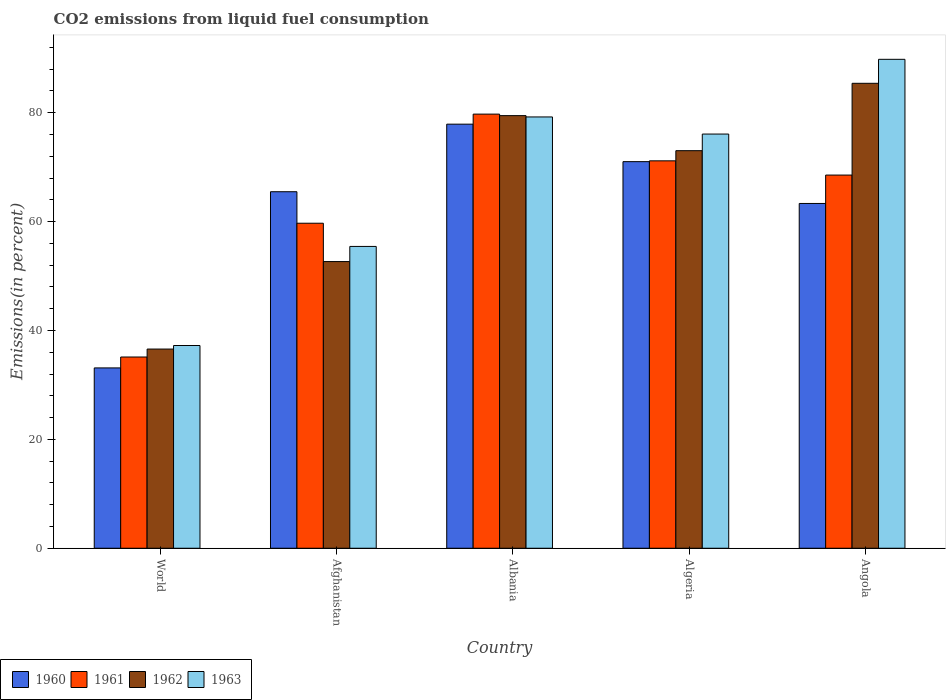How many different coloured bars are there?
Provide a succinct answer. 4. Are the number of bars per tick equal to the number of legend labels?
Offer a terse response. Yes. Are the number of bars on each tick of the X-axis equal?
Offer a terse response. Yes. How many bars are there on the 1st tick from the left?
Make the answer very short. 4. How many bars are there on the 5th tick from the right?
Provide a succinct answer. 4. What is the label of the 3rd group of bars from the left?
Your answer should be compact. Albania. What is the total CO2 emitted in 1963 in Albania?
Make the answer very short. 79.23. Across all countries, what is the maximum total CO2 emitted in 1960?
Your response must be concise. 77.9. Across all countries, what is the minimum total CO2 emitted in 1962?
Offer a very short reply. 36.59. In which country was the total CO2 emitted in 1960 maximum?
Your response must be concise. Albania. What is the total total CO2 emitted in 1962 in the graph?
Your answer should be compact. 327.14. What is the difference between the total CO2 emitted in 1960 in Afghanistan and that in World?
Your answer should be compact. 32.36. What is the difference between the total CO2 emitted in 1962 in Angola and the total CO2 emitted in 1960 in Algeria?
Provide a short and direct response. 14.39. What is the average total CO2 emitted in 1961 per country?
Give a very brief answer. 62.86. What is the difference between the total CO2 emitted of/in 1960 and total CO2 emitted of/in 1963 in World?
Give a very brief answer. -4.11. What is the ratio of the total CO2 emitted in 1962 in Albania to that in Angola?
Your answer should be very brief. 0.93. Is the difference between the total CO2 emitted in 1960 in Afghanistan and Angola greater than the difference between the total CO2 emitted in 1963 in Afghanistan and Angola?
Ensure brevity in your answer.  Yes. What is the difference between the highest and the second highest total CO2 emitted in 1960?
Keep it short and to the point. -12.41. What is the difference between the highest and the lowest total CO2 emitted in 1960?
Your answer should be very brief. 44.77. Is the sum of the total CO2 emitted in 1963 in Algeria and World greater than the maximum total CO2 emitted in 1962 across all countries?
Give a very brief answer. Yes. Are all the bars in the graph horizontal?
Offer a terse response. No. What is the difference between two consecutive major ticks on the Y-axis?
Make the answer very short. 20. Are the values on the major ticks of Y-axis written in scientific E-notation?
Keep it short and to the point. No. Does the graph contain any zero values?
Offer a terse response. No. Does the graph contain grids?
Your answer should be very brief. No. How are the legend labels stacked?
Offer a terse response. Horizontal. What is the title of the graph?
Offer a very short reply. CO2 emissions from liquid fuel consumption. What is the label or title of the X-axis?
Offer a very short reply. Country. What is the label or title of the Y-axis?
Ensure brevity in your answer.  Emissions(in percent). What is the Emissions(in percent) of 1960 in World?
Make the answer very short. 33.13. What is the Emissions(in percent) of 1961 in World?
Provide a short and direct response. 35.13. What is the Emissions(in percent) in 1962 in World?
Ensure brevity in your answer.  36.59. What is the Emissions(in percent) of 1963 in World?
Keep it short and to the point. 37.24. What is the Emissions(in percent) in 1960 in Afghanistan?
Offer a very short reply. 65.49. What is the Emissions(in percent) in 1961 in Afghanistan?
Provide a short and direct response. 59.7. What is the Emissions(in percent) in 1962 in Afghanistan?
Offer a terse response. 52.66. What is the Emissions(in percent) in 1963 in Afghanistan?
Ensure brevity in your answer.  55.44. What is the Emissions(in percent) in 1960 in Albania?
Offer a very short reply. 77.9. What is the Emissions(in percent) in 1961 in Albania?
Make the answer very short. 79.74. What is the Emissions(in percent) in 1962 in Albania?
Provide a succinct answer. 79.46. What is the Emissions(in percent) in 1963 in Albania?
Your response must be concise. 79.23. What is the Emissions(in percent) of 1960 in Algeria?
Keep it short and to the point. 71.01. What is the Emissions(in percent) of 1961 in Algeria?
Give a very brief answer. 71.16. What is the Emissions(in percent) of 1962 in Algeria?
Offer a very short reply. 73.03. What is the Emissions(in percent) of 1963 in Algeria?
Keep it short and to the point. 76.08. What is the Emissions(in percent) in 1960 in Angola?
Offer a terse response. 63.33. What is the Emissions(in percent) in 1961 in Angola?
Offer a very short reply. 68.55. What is the Emissions(in percent) of 1962 in Angola?
Your answer should be very brief. 85.4. What is the Emissions(in percent) of 1963 in Angola?
Your answer should be very brief. 89.81. Across all countries, what is the maximum Emissions(in percent) in 1960?
Your answer should be compact. 77.9. Across all countries, what is the maximum Emissions(in percent) in 1961?
Keep it short and to the point. 79.74. Across all countries, what is the maximum Emissions(in percent) in 1962?
Provide a short and direct response. 85.4. Across all countries, what is the maximum Emissions(in percent) in 1963?
Your answer should be very brief. 89.81. Across all countries, what is the minimum Emissions(in percent) of 1960?
Your answer should be compact. 33.13. Across all countries, what is the minimum Emissions(in percent) in 1961?
Your answer should be very brief. 35.13. Across all countries, what is the minimum Emissions(in percent) in 1962?
Provide a succinct answer. 36.59. Across all countries, what is the minimum Emissions(in percent) in 1963?
Offer a terse response. 37.24. What is the total Emissions(in percent) of 1960 in the graph?
Offer a very short reply. 310.86. What is the total Emissions(in percent) in 1961 in the graph?
Offer a terse response. 314.28. What is the total Emissions(in percent) in 1962 in the graph?
Provide a short and direct response. 327.14. What is the total Emissions(in percent) in 1963 in the graph?
Provide a short and direct response. 337.8. What is the difference between the Emissions(in percent) in 1960 in World and that in Afghanistan?
Your response must be concise. -32.36. What is the difference between the Emissions(in percent) in 1961 in World and that in Afghanistan?
Provide a short and direct response. -24.57. What is the difference between the Emissions(in percent) of 1962 in World and that in Afghanistan?
Make the answer very short. -16.07. What is the difference between the Emissions(in percent) of 1963 in World and that in Afghanistan?
Offer a very short reply. -18.2. What is the difference between the Emissions(in percent) in 1960 in World and that in Albania?
Provide a short and direct response. -44.77. What is the difference between the Emissions(in percent) of 1961 in World and that in Albania?
Provide a short and direct response. -44.61. What is the difference between the Emissions(in percent) in 1962 in World and that in Albania?
Your answer should be very brief. -42.88. What is the difference between the Emissions(in percent) of 1963 in World and that in Albania?
Keep it short and to the point. -41.99. What is the difference between the Emissions(in percent) of 1960 in World and that in Algeria?
Keep it short and to the point. -37.89. What is the difference between the Emissions(in percent) in 1961 in World and that in Algeria?
Your answer should be very brief. -36.03. What is the difference between the Emissions(in percent) in 1962 in World and that in Algeria?
Provide a short and direct response. -36.44. What is the difference between the Emissions(in percent) of 1963 in World and that in Algeria?
Make the answer very short. -38.84. What is the difference between the Emissions(in percent) in 1960 in World and that in Angola?
Keep it short and to the point. -30.21. What is the difference between the Emissions(in percent) of 1961 in World and that in Angola?
Ensure brevity in your answer.  -33.42. What is the difference between the Emissions(in percent) of 1962 in World and that in Angola?
Provide a short and direct response. -48.82. What is the difference between the Emissions(in percent) in 1963 in World and that in Angola?
Offer a terse response. -52.57. What is the difference between the Emissions(in percent) in 1960 in Afghanistan and that in Albania?
Make the answer very short. -12.41. What is the difference between the Emissions(in percent) of 1961 in Afghanistan and that in Albania?
Your response must be concise. -20.04. What is the difference between the Emissions(in percent) of 1962 in Afghanistan and that in Albania?
Your answer should be compact. -26.8. What is the difference between the Emissions(in percent) in 1963 in Afghanistan and that in Albania?
Provide a short and direct response. -23.78. What is the difference between the Emissions(in percent) of 1960 in Afghanistan and that in Algeria?
Make the answer very short. -5.53. What is the difference between the Emissions(in percent) of 1961 in Afghanistan and that in Algeria?
Your response must be concise. -11.46. What is the difference between the Emissions(in percent) of 1962 in Afghanistan and that in Algeria?
Your answer should be compact. -20.37. What is the difference between the Emissions(in percent) in 1963 in Afghanistan and that in Algeria?
Your response must be concise. -20.64. What is the difference between the Emissions(in percent) in 1960 in Afghanistan and that in Angola?
Your response must be concise. 2.15. What is the difference between the Emissions(in percent) in 1961 in Afghanistan and that in Angola?
Ensure brevity in your answer.  -8.85. What is the difference between the Emissions(in percent) of 1962 in Afghanistan and that in Angola?
Ensure brevity in your answer.  -32.74. What is the difference between the Emissions(in percent) in 1963 in Afghanistan and that in Angola?
Offer a terse response. -34.37. What is the difference between the Emissions(in percent) in 1960 in Albania and that in Algeria?
Keep it short and to the point. 6.89. What is the difference between the Emissions(in percent) of 1961 in Albania and that in Algeria?
Ensure brevity in your answer.  8.58. What is the difference between the Emissions(in percent) in 1962 in Albania and that in Algeria?
Offer a terse response. 6.44. What is the difference between the Emissions(in percent) in 1963 in Albania and that in Algeria?
Your answer should be very brief. 3.14. What is the difference between the Emissions(in percent) of 1960 in Albania and that in Angola?
Your answer should be very brief. 14.57. What is the difference between the Emissions(in percent) of 1961 in Albania and that in Angola?
Your response must be concise. 11.19. What is the difference between the Emissions(in percent) in 1962 in Albania and that in Angola?
Your response must be concise. -5.94. What is the difference between the Emissions(in percent) in 1963 in Albania and that in Angola?
Offer a very short reply. -10.58. What is the difference between the Emissions(in percent) in 1960 in Algeria and that in Angola?
Offer a terse response. 7.68. What is the difference between the Emissions(in percent) of 1961 in Algeria and that in Angola?
Offer a terse response. 2.61. What is the difference between the Emissions(in percent) of 1962 in Algeria and that in Angola?
Your answer should be compact. -12.38. What is the difference between the Emissions(in percent) of 1963 in Algeria and that in Angola?
Your answer should be very brief. -13.73. What is the difference between the Emissions(in percent) of 1960 in World and the Emissions(in percent) of 1961 in Afghanistan?
Provide a short and direct response. -26.58. What is the difference between the Emissions(in percent) of 1960 in World and the Emissions(in percent) of 1962 in Afghanistan?
Your response must be concise. -19.53. What is the difference between the Emissions(in percent) in 1960 in World and the Emissions(in percent) in 1963 in Afghanistan?
Ensure brevity in your answer.  -22.32. What is the difference between the Emissions(in percent) in 1961 in World and the Emissions(in percent) in 1962 in Afghanistan?
Provide a short and direct response. -17.53. What is the difference between the Emissions(in percent) in 1961 in World and the Emissions(in percent) in 1963 in Afghanistan?
Make the answer very short. -20.31. What is the difference between the Emissions(in percent) in 1962 in World and the Emissions(in percent) in 1963 in Afghanistan?
Offer a very short reply. -18.85. What is the difference between the Emissions(in percent) in 1960 in World and the Emissions(in percent) in 1961 in Albania?
Ensure brevity in your answer.  -46.62. What is the difference between the Emissions(in percent) in 1960 in World and the Emissions(in percent) in 1962 in Albania?
Make the answer very short. -46.34. What is the difference between the Emissions(in percent) in 1960 in World and the Emissions(in percent) in 1963 in Albania?
Your answer should be compact. -46.1. What is the difference between the Emissions(in percent) in 1961 in World and the Emissions(in percent) in 1962 in Albania?
Your response must be concise. -44.34. What is the difference between the Emissions(in percent) in 1961 in World and the Emissions(in percent) in 1963 in Albania?
Offer a terse response. -44.1. What is the difference between the Emissions(in percent) of 1962 in World and the Emissions(in percent) of 1963 in Albania?
Give a very brief answer. -42.64. What is the difference between the Emissions(in percent) in 1960 in World and the Emissions(in percent) in 1961 in Algeria?
Your answer should be very brief. -38.04. What is the difference between the Emissions(in percent) of 1960 in World and the Emissions(in percent) of 1962 in Algeria?
Your answer should be very brief. -39.9. What is the difference between the Emissions(in percent) of 1960 in World and the Emissions(in percent) of 1963 in Algeria?
Provide a succinct answer. -42.96. What is the difference between the Emissions(in percent) in 1961 in World and the Emissions(in percent) in 1962 in Algeria?
Your response must be concise. -37.9. What is the difference between the Emissions(in percent) in 1961 in World and the Emissions(in percent) in 1963 in Algeria?
Your answer should be very brief. -40.95. What is the difference between the Emissions(in percent) in 1962 in World and the Emissions(in percent) in 1963 in Algeria?
Provide a succinct answer. -39.49. What is the difference between the Emissions(in percent) in 1960 in World and the Emissions(in percent) in 1961 in Angola?
Give a very brief answer. -35.42. What is the difference between the Emissions(in percent) in 1960 in World and the Emissions(in percent) in 1962 in Angola?
Give a very brief answer. -52.28. What is the difference between the Emissions(in percent) of 1960 in World and the Emissions(in percent) of 1963 in Angola?
Provide a short and direct response. -56.68. What is the difference between the Emissions(in percent) in 1961 in World and the Emissions(in percent) in 1962 in Angola?
Provide a short and direct response. -50.28. What is the difference between the Emissions(in percent) in 1961 in World and the Emissions(in percent) in 1963 in Angola?
Make the answer very short. -54.68. What is the difference between the Emissions(in percent) of 1962 in World and the Emissions(in percent) of 1963 in Angola?
Provide a short and direct response. -53.22. What is the difference between the Emissions(in percent) in 1960 in Afghanistan and the Emissions(in percent) in 1961 in Albania?
Your answer should be compact. -14.26. What is the difference between the Emissions(in percent) in 1960 in Afghanistan and the Emissions(in percent) in 1962 in Albania?
Offer a terse response. -13.98. What is the difference between the Emissions(in percent) in 1960 in Afghanistan and the Emissions(in percent) in 1963 in Albania?
Ensure brevity in your answer.  -13.74. What is the difference between the Emissions(in percent) in 1961 in Afghanistan and the Emissions(in percent) in 1962 in Albania?
Your answer should be compact. -19.76. What is the difference between the Emissions(in percent) in 1961 in Afghanistan and the Emissions(in percent) in 1963 in Albania?
Ensure brevity in your answer.  -19.52. What is the difference between the Emissions(in percent) in 1962 in Afghanistan and the Emissions(in percent) in 1963 in Albania?
Provide a succinct answer. -26.57. What is the difference between the Emissions(in percent) of 1960 in Afghanistan and the Emissions(in percent) of 1961 in Algeria?
Give a very brief answer. -5.67. What is the difference between the Emissions(in percent) of 1960 in Afghanistan and the Emissions(in percent) of 1962 in Algeria?
Your response must be concise. -7.54. What is the difference between the Emissions(in percent) of 1960 in Afghanistan and the Emissions(in percent) of 1963 in Algeria?
Your answer should be compact. -10.59. What is the difference between the Emissions(in percent) in 1961 in Afghanistan and the Emissions(in percent) in 1962 in Algeria?
Keep it short and to the point. -13.33. What is the difference between the Emissions(in percent) in 1961 in Afghanistan and the Emissions(in percent) in 1963 in Algeria?
Your answer should be very brief. -16.38. What is the difference between the Emissions(in percent) of 1962 in Afghanistan and the Emissions(in percent) of 1963 in Algeria?
Your answer should be compact. -23.42. What is the difference between the Emissions(in percent) in 1960 in Afghanistan and the Emissions(in percent) in 1961 in Angola?
Your answer should be very brief. -3.06. What is the difference between the Emissions(in percent) of 1960 in Afghanistan and the Emissions(in percent) of 1962 in Angola?
Keep it short and to the point. -19.92. What is the difference between the Emissions(in percent) of 1960 in Afghanistan and the Emissions(in percent) of 1963 in Angola?
Your answer should be compact. -24.32. What is the difference between the Emissions(in percent) in 1961 in Afghanistan and the Emissions(in percent) in 1962 in Angola?
Ensure brevity in your answer.  -25.7. What is the difference between the Emissions(in percent) of 1961 in Afghanistan and the Emissions(in percent) of 1963 in Angola?
Offer a terse response. -30.11. What is the difference between the Emissions(in percent) of 1962 in Afghanistan and the Emissions(in percent) of 1963 in Angola?
Your response must be concise. -37.15. What is the difference between the Emissions(in percent) of 1960 in Albania and the Emissions(in percent) of 1961 in Algeria?
Provide a succinct answer. 6.74. What is the difference between the Emissions(in percent) of 1960 in Albania and the Emissions(in percent) of 1962 in Algeria?
Your answer should be very brief. 4.87. What is the difference between the Emissions(in percent) in 1960 in Albania and the Emissions(in percent) in 1963 in Algeria?
Provide a short and direct response. 1.82. What is the difference between the Emissions(in percent) of 1961 in Albania and the Emissions(in percent) of 1962 in Algeria?
Your answer should be compact. 6.72. What is the difference between the Emissions(in percent) in 1961 in Albania and the Emissions(in percent) in 1963 in Algeria?
Offer a terse response. 3.66. What is the difference between the Emissions(in percent) of 1962 in Albania and the Emissions(in percent) of 1963 in Algeria?
Keep it short and to the point. 3.38. What is the difference between the Emissions(in percent) in 1960 in Albania and the Emissions(in percent) in 1961 in Angola?
Provide a short and direct response. 9.35. What is the difference between the Emissions(in percent) in 1960 in Albania and the Emissions(in percent) in 1962 in Angola?
Give a very brief answer. -7.51. What is the difference between the Emissions(in percent) of 1960 in Albania and the Emissions(in percent) of 1963 in Angola?
Provide a short and direct response. -11.91. What is the difference between the Emissions(in percent) of 1961 in Albania and the Emissions(in percent) of 1962 in Angola?
Keep it short and to the point. -5.66. What is the difference between the Emissions(in percent) in 1961 in Albania and the Emissions(in percent) in 1963 in Angola?
Make the answer very short. -10.07. What is the difference between the Emissions(in percent) of 1962 in Albania and the Emissions(in percent) of 1963 in Angola?
Offer a very short reply. -10.34. What is the difference between the Emissions(in percent) of 1960 in Algeria and the Emissions(in percent) of 1961 in Angola?
Keep it short and to the point. 2.46. What is the difference between the Emissions(in percent) of 1960 in Algeria and the Emissions(in percent) of 1962 in Angola?
Make the answer very short. -14.39. What is the difference between the Emissions(in percent) in 1960 in Algeria and the Emissions(in percent) in 1963 in Angola?
Your answer should be compact. -18.8. What is the difference between the Emissions(in percent) in 1961 in Algeria and the Emissions(in percent) in 1962 in Angola?
Your answer should be compact. -14.24. What is the difference between the Emissions(in percent) in 1961 in Algeria and the Emissions(in percent) in 1963 in Angola?
Your answer should be very brief. -18.65. What is the difference between the Emissions(in percent) of 1962 in Algeria and the Emissions(in percent) of 1963 in Angola?
Keep it short and to the point. -16.78. What is the average Emissions(in percent) of 1960 per country?
Offer a very short reply. 62.17. What is the average Emissions(in percent) in 1961 per country?
Offer a terse response. 62.86. What is the average Emissions(in percent) in 1962 per country?
Offer a very short reply. 65.43. What is the average Emissions(in percent) in 1963 per country?
Your response must be concise. 67.56. What is the difference between the Emissions(in percent) of 1960 and Emissions(in percent) of 1961 in World?
Make the answer very short. -2. What is the difference between the Emissions(in percent) of 1960 and Emissions(in percent) of 1962 in World?
Give a very brief answer. -3.46. What is the difference between the Emissions(in percent) of 1960 and Emissions(in percent) of 1963 in World?
Your answer should be very brief. -4.11. What is the difference between the Emissions(in percent) in 1961 and Emissions(in percent) in 1962 in World?
Provide a short and direct response. -1.46. What is the difference between the Emissions(in percent) in 1961 and Emissions(in percent) in 1963 in World?
Give a very brief answer. -2.11. What is the difference between the Emissions(in percent) in 1962 and Emissions(in percent) in 1963 in World?
Offer a very short reply. -0.65. What is the difference between the Emissions(in percent) in 1960 and Emissions(in percent) in 1961 in Afghanistan?
Keep it short and to the point. 5.79. What is the difference between the Emissions(in percent) of 1960 and Emissions(in percent) of 1962 in Afghanistan?
Offer a very short reply. 12.83. What is the difference between the Emissions(in percent) in 1960 and Emissions(in percent) in 1963 in Afghanistan?
Make the answer very short. 10.05. What is the difference between the Emissions(in percent) of 1961 and Emissions(in percent) of 1962 in Afghanistan?
Offer a very short reply. 7.04. What is the difference between the Emissions(in percent) in 1961 and Emissions(in percent) in 1963 in Afghanistan?
Your answer should be very brief. 4.26. What is the difference between the Emissions(in percent) of 1962 and Emissions(in percent) of 1963 in Afghanistan?
Give a very brief answer. -2.78. What is the difference between the Emissions(in percent) of 1960 and Emissions(in percent) of 1961 in Albania?
Keep it short and to the point. -1.84. What is the difference between the Emissions(in percent) of 1960 and Emissions(in percent) of 1962 in Albania?
Offer a terse response. -1.57. What is the difference between the Emissions(in percent) in 1960 and Emissions(in percent) in 1963 in Albania?
Your answer should be very brief. -1.33. What is the difference between the Emissions(in percent) in 1961 and Emissions(in percent) in 1962 in Albania?
Your answer should be compact. 0.28. What is the difference between the Emissions(in percent) in 1961 and Emissions(in percent) in 1963 in Albania?
Offer a very short reply. 0.52. What is the difference between the Emissions(in percent) in 1962 and Emissions(in percent) in 1963 in Albania?
Give a very brief answer. 0.24. What is the difference between the Emissions(in percent) in 1960 and Emissions(in percent) in 1961 in Algeria?
Offer a terse response. -0.15. What is the difference between the Emissions(in percent) in 1960 and Emissions(in percent) in 1962 in Algeria?
Offer a terse response. -2.02. What is the difference between the Emissions(in percent) of 1960 and Emissions(in percent) of 1963 in Algeria?
Make the answer very short. -5.07. What is the difference between the Emissions(in percent) in 1961 and Emissions(in percent) in 1962 in Algeria?
Keep it short and to the point. -1.87. What is the difference between the Emissions(in percent) of 1961 and Emissions(in percent) of 1963 in Algeria?
Ensure brevity in your answer.  -4.92. What is the difference between the Emissions(in percent) in 1962 and Emissions(in percent) in 1963 in Algeria?
Provide a succinct answer. -3.05. What is the difference between the Emissions(in percent) in 1960 and Emissions(in percent) in 1961 in Angola?
Keep it short and to the point. -5.22. What is the difference between the Emissions(in percent) of 1960 and Emissions(in percent) of 1962 in Angola?
Your answer should be compact. -22.07. What is the difference between the Emissions(in percent) of 1960 and Emissions(in percent) of 1963 in Angola?
Make the answer very short. -26.48. What is the difference between the Emissions(in percent) of 1961 and Emissions(in percent) of 1962 in Angola?
Your response must be concise. -16.86. What is the difference between the Emissions(in percent) in 1961 and Emissions(in percent) in 1963 in Angola?
Ensure brevity in your answer.  -21.26. What is the difference between the Emissions(in percent) in 1962 and Emissions(in percent) in 1963 in Angola?
Give a very brief answer. -4.41. What is the ratio of the Emissions(in percent) of 1960 in World to that in Afghanistan?
Your response must be concise. 0.51. What is the ratio of the Emissions(in percent) in 1961 in World to that in Afghanistan?
Offer a very short reply. 0.59. What is the ratio of the Emissions(in percent) of 1962 in World to that in Afghanistan?
Your response must be concise. 0.69. What is the ratio of the Emissions(in percent) of 1963 in World to that in Afghanistan?
Your answer should be very brief. 0.67. What is the ratio of the Emissions(in percent) in 1960 in World to that in Albania?
Make the answer very short. 0.43. What is the ratio of the Emissions(in percent) in 1961 in World to that in Albania?
Offer a terse response. 0.44. What is the ratio of the Emissions(in percent) of 1962 in World to that in Albania?
Make the answer very short. 0.46. What is the ratio of the Emissions(in percent) of 1963 in World to that in Albania?
Offer a very short reply. 0.47. What is the ratio of the Emissions(in percent) of 1960 in World to that in Algeria?
Your answer should be very brief. 0.47. What is the ratio of the Emissions(in percent) in 1961 in World to that in Algeria?
Ensure brevity in your answer.  0.49. What is the ratio of the Emissions(in percent) in 1962 in World to that in Algeria?
Ensure brevity in your answer.  0.5. What is the ratio of the Emissions(in percent) in 1963 in World to that in Algeria?
Keep it short and to the point. 0.49. What is the ratio of the Emissions(in percent) of 1960 in World to that in Angola?
Make the answer very short. 0.52. What is the ratio of the Emissions(in percent) of 1961 in World to that in Angola?
Give a very brief answer. 0.51. What is the ratio of the Emissions(in percent) in 1962 in World to that in Angola?
Your answer should be very brief. 0.43. What is the ratio of the Emissions(in percent) in 1963 in World to that in Angola?
Your response must be concise. 0.41. What is the ratio of the Emissions(in percent) of 1960 in Afghanistan to that in Albania?
Your response must be concise. 0.84. What is the ratio of the Emissions(in percent) of 1961 in Afghanistan to that in Albania?
Your answer should be very brief. 0.75. What is the ratio of the Emissions(in percent) of 1962 in Afghanistan to that in Albania?
Keep it short and to the point. 0.66. What is the ratio of the Emissions(in percent) in 1963 in Afghanistan to that in Albania?
Keep it short and to the point. 0.7. What is the ratio of the Emissions(in percent) in 1960 in Afghanistan to that in Algeria?
Offer a terse response. 0.92. What is the ratio of the Emissions(in percent) of 1961 in Afghanistan to that in Algeria?
Offer a terse response. 0.84. What is the ratio of the Emissions(in percent) in 1962 in Afghanistan to that in Algeria?
Your answer should be very brief. 0.72. What is the ratio of the Emissions(in percent) in 1963 in Afghanistan to that in Algeria?
Make the answer very short. 0.73. What is the ratio of the Emissions(in percent) of 1960 in Afghanistan to that in Angola?
Your answer should be compact. 1.03. What is the ratio of the Emissions(in percent) of 1961 in Afghanistan to that in Angola?
Your answer should be compact. 0.87. What is the ratio of the Emissions(in percent) of 1962 in Afghanistan to that in Angola?
Your answer should be very brief. 0.62. What is the ratio of the Emissions(in percent) in 1963 in Afghanistan to that in Angola?
Provide a short and direct response. 0.62. What is the ratio of the Emissions(in percent) in 1960 in Albania to that in Algeria?
Provide a short and direct response. 1.1. What is the ratio of the Emissions(in percent) in 1961 in Albania to that in Algeria?
Ensure brevity in your answer.  1.12. What is the ratio of the Emissions(in percent) of 1962 in Albania to that in Algeria?
Your answer should be very brief. 1.09. What is the ratio of the Emissions(in percent) in 1963 in Albania to that in Algeria?
Offer a terse response. 1.04. What is the ratio of the Emissions(in percent) in 1960 in Albania to that in Angola?
Keep it short and to the point. 1.23. What is the ratio of the Emissions(in percent) in 1961 in Albania to that in Angola?
Give a very brief answer. 1.16. What is the ratio of the Emissions(in percent) of 1962 in Albania to that in Angola?
Keep it short and to the point. 0.93. What is the ratio of the Emissions(in percent) of 1963 in Albania to that in Angola?
Offer a very short reply. 0.88. What is the ratio of the Emissions(in percent) in 1960 in Algeria to that in Angola?
Offer a very short reply. 1.12. What is the ratio of the Emissions(in percent) of 1961 in Algeria to that in Angola?
Give a very brief answer. 1.04. What is the ratio of the Emissions(in percent) in 1962 in Algeria to that in Angola?
Ensure brevity in your answer.  0.86. What is the ratio of the Emissions(in percent) in 1963 in Algeria to that in Angola?
Offer a terse response. 0.85. What is the difference between the highest and the second highest Emissions(in percent) in 1960?
Give a very brief answer. 6.89. What is the difference between the highest and the second highest Emissions(in percent) of 1961?
Provide a succinct answer. 8.58. What is the difference between the highest and the second highest Emissions(in percent) of 1962?
Provide a succinct answer. 5.94. What is the difference between the highest and the second highest Emissions(in percent) of 1963?
Provide a succinct answer. 10.58. What is the difference between the highest and the lowest Emissions(in percent) of 1960?
Provide a short and direct response. 44.77. What is the difference between the highest and the lowest Emissions(in percent) in 1961?
Offer a very short reply. 44.61. What is the difference between the highest and the lowest Emissions(in percent) in 1962?
Ensure brevity in your answer.  48.82. What is the difference between the highest and the lowest Emissions(in percent) in 1963?
Your answer should be compact. 52.57. 